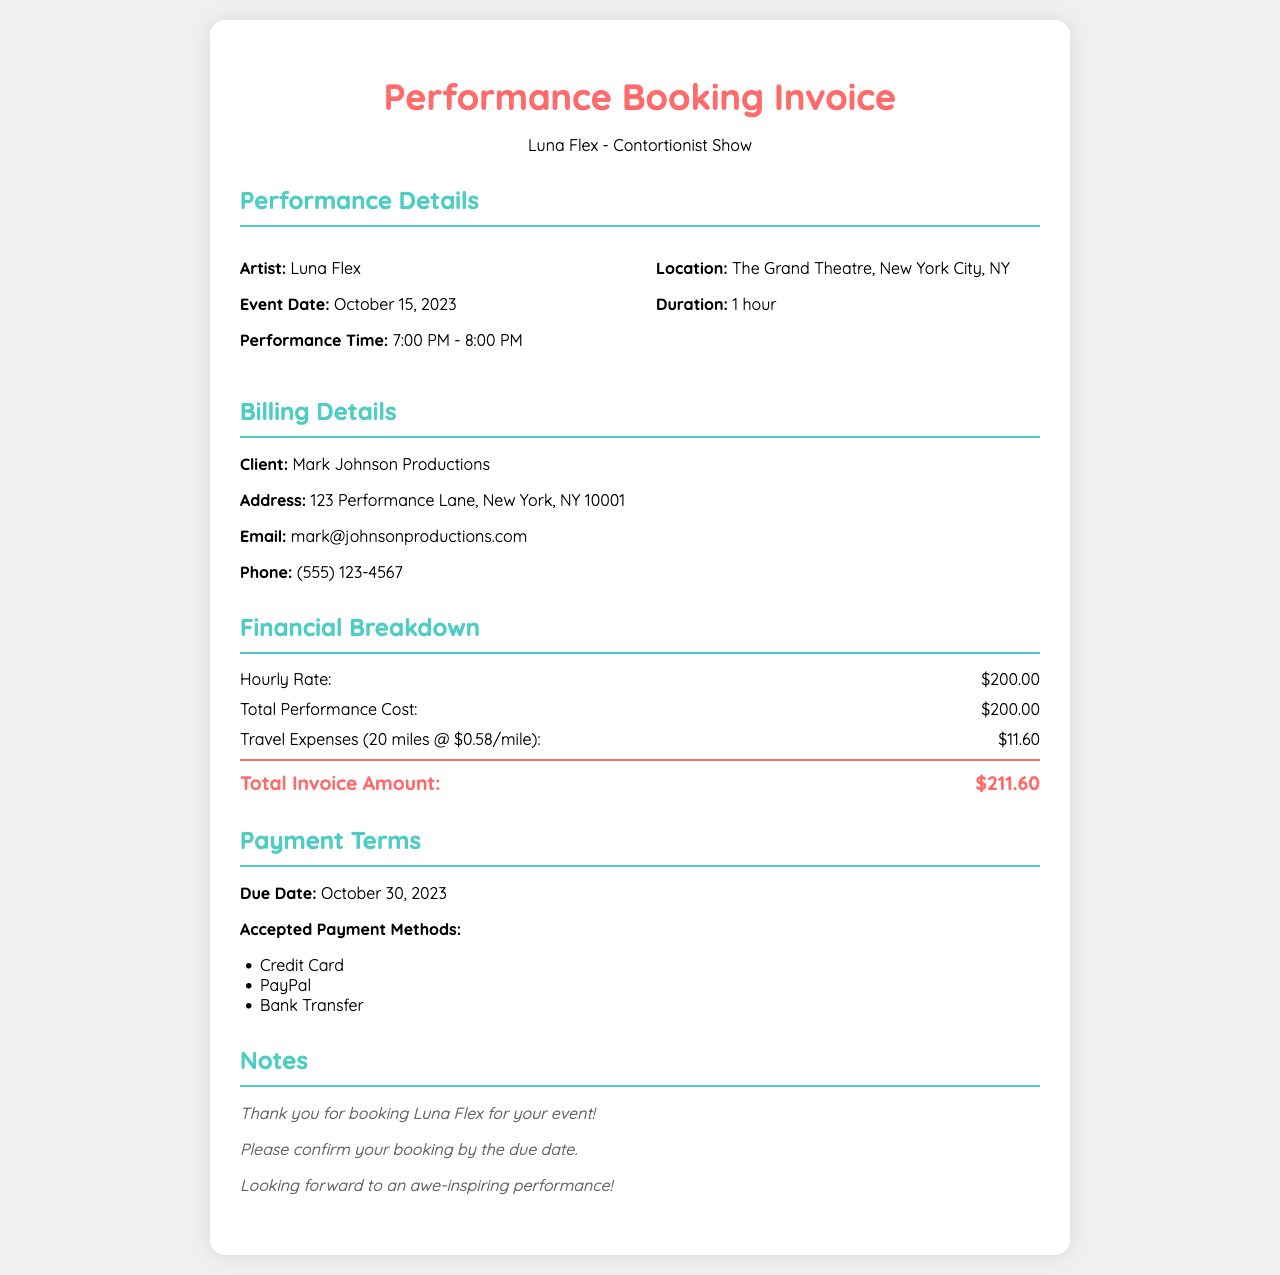What is the name of the artist? The name of the artist is mentioned in the performance details section of the document.
Answer: Luna Flex What is the total invoice amount? The total invoice amount is calculated from the financial breakdown section.
Answer: $211.60 What is the hourly rate for the performance? The hourly rate can be found under the financial breakdown section.
Answer: $200.00 What is the duration of the performance? The duration is specified in the performance details section of the document.
Answer: 1 hour What is the due date for payment? The due date is listed in the payment terms section of the document.
Answer: October 30, 2023 How many miles were traveled for the performance? The number of miles is indicated in the travel expenses entry in the financial breakdown.
Answer: 20 miles What are the accepted payment methods? The accepted payment methods are listed in the payment terms section.
Answer: Credit Card, PayPal, Bank Transfer Who is the client for this invoice? The client's name is provided in the billing details section.
Answer: Mark Johnson Productions What is the event location? The event location is specified in the performance details section.
Answer: The Grand Theatre, New York City, NY 